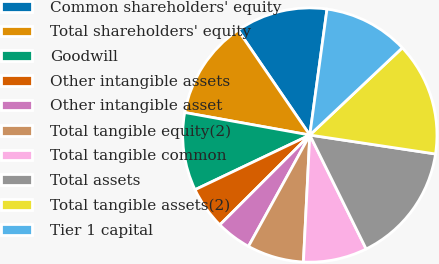<chart> <loc_0><loc_0><loc_500><loc_500><pie_chart><fcel>Common shareholders' equity<fcel>Total shareholders' equity<fcel>Goodwill<fcel>Other intangible assets<fcel>Other intangible asset<fcel>Total tangible equity(2)<fcel>Total tangible common<fcel>Total assets<fcel>Total tangible assets(2)<fcel>Tier 1 capital<nl><fcel>11.71%<fcel>12.61%<fcel>9.91%<fcel>5.41%<fcel>4.5%<fcel>7.21%<fcel>8.11%<fcel>15.31%<fcel>14.41%<fcel>10.81%<nl></chart> 